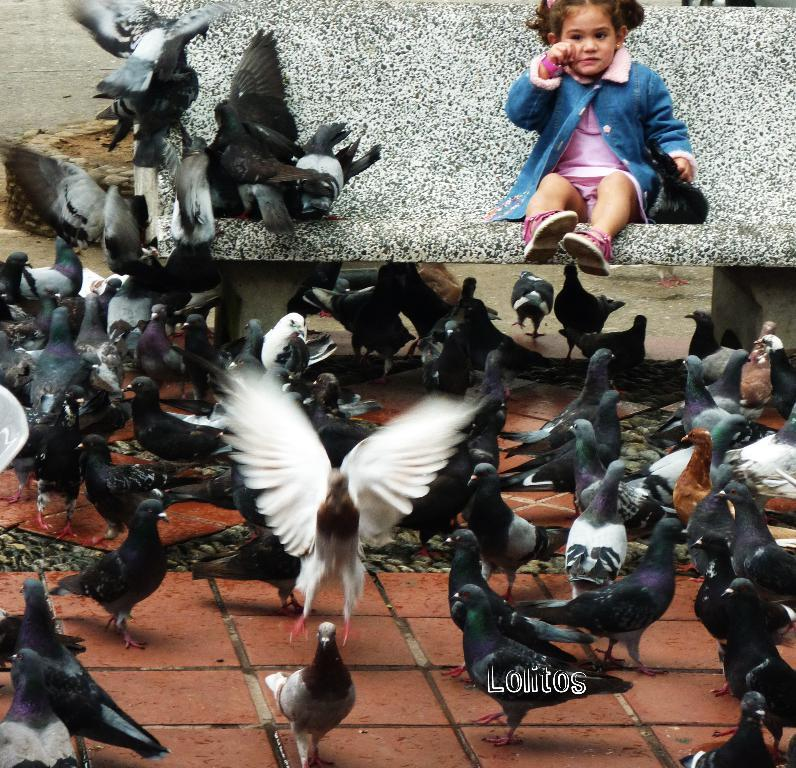What can be seen on the road in the foreground of the image? There are flocks of birds on the road in the foreground. Where is the kid located in the image? The kid is sitting on a bench in the top part of the image. When was the image taken? The image was taken during the day. What grade is the kid in, as seen in the image? There is no information about the kid's grade in the image. What type of fang can be seen in the image? There are no fangs present in the image. 